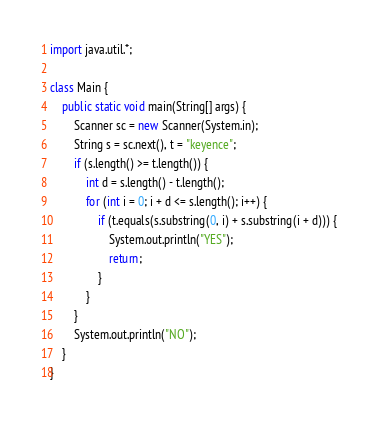<code> <loc_0><loc_0><loc_500><loc_500><_Java_>import java.util.*;

class Main {
	public static void main(String[] args) {
		Scanner sc = new Scanner(System.in);
		String s = sc.next(), t = "keyence";
		if (s.length() >= t.length()) {
			int d = s.length() - t.length();
			for (int i = 0; i + d <= s.length(); i++) {
				if (t.equals(s.substring(0, i) + s.substring(i + d))) {
					System.out.println("YES");
					return;
				}
			}
		}
		System.out.println("NO");
	}
}</code> 